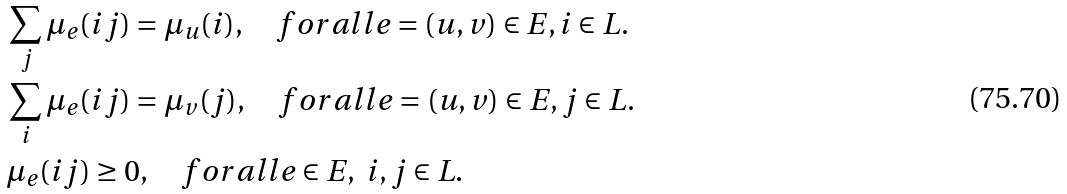<formula> <loc_0><loc_0><loc_500><loc_500>& \sum _ { j } \mu _ { e } ( i j ) = \mu _ { u } ( i ) , \quad f o r a l l e = ( u , v ) \in E , i \in L . \\ & \sum _ { i } \mu _ { e } ( i j ) = \mu _ { v } ( j ) , \quad f o r a l l e = ( u , v ) \in E , j \in L . \\ & \mu _ { e } ( i j ) \geq 0 , \quad f o r a l l e \in E , \ i , j \in L .</formula> 